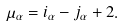<formula> <loc_0><loc_0><loc_500><loc_500>\mu _ { \alpha } = i _ { \alpha } - j _ { \alpha } + 2 .</formula> 